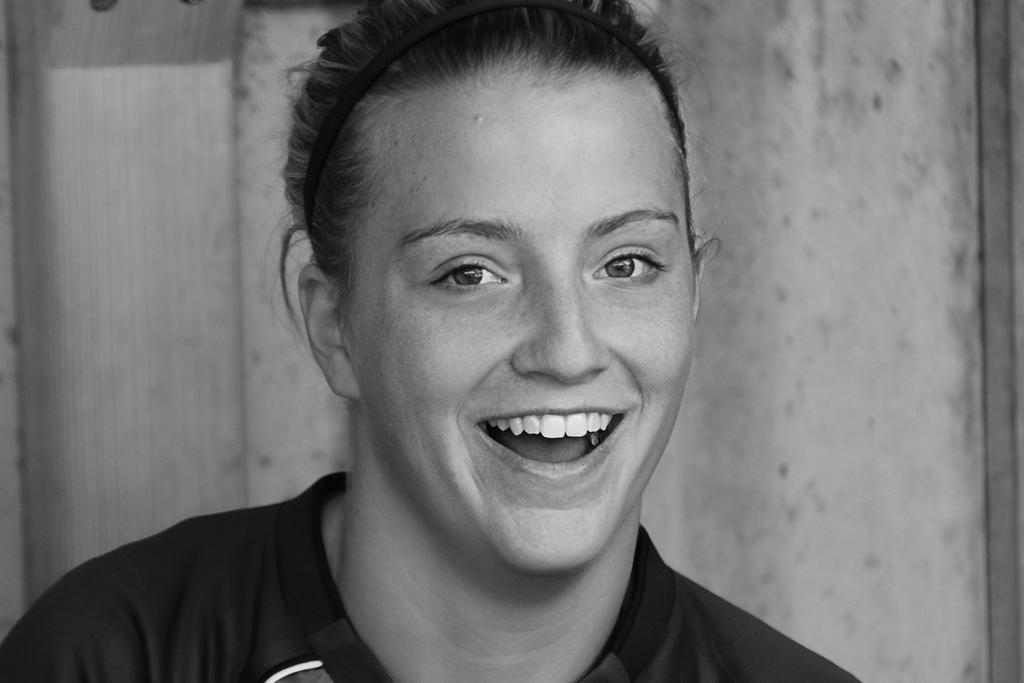Who is present in the image? There is a woman in the image. What is the woman doing in the image? The woman is smiling in the image. What is the color scheme of the image? The image is black and white. What can be seen in the background of the image? There is a curtain in the background of the image. What is the rate at which the banana is spinning on the wheel in the image? There is no banana or wheel present in the image, so it is not possible to determine a rate of spinning. 